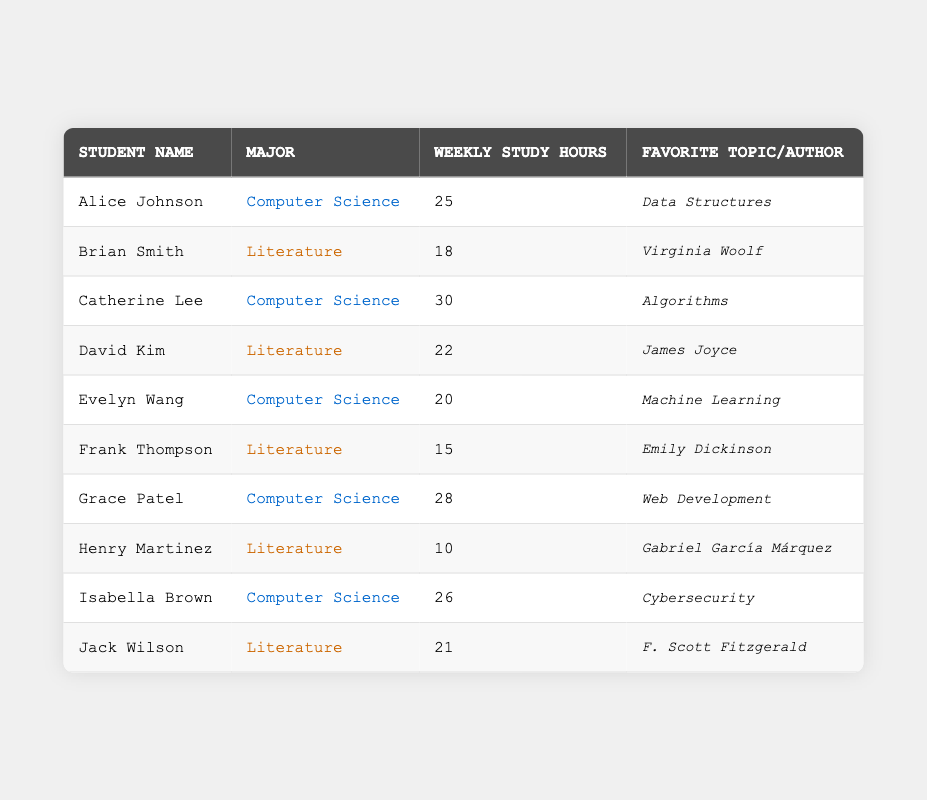What is the name of the student who studies the topic "Web Development"? In the table, I look for the "Favorite Topic" column and find "Web Development." The corresponding student name in that row is "Grace Patel."
Answer: Grace Patel What is the weekly study hour of Brian Smith? To find Brian Smith's study hours, I locate the row with his name in the table and read the value in the "Weekly Study Hours" column, which is 18.
Answer: 18 Which major has the highest weekly study hour among students in the table? I will compare the "Weekly Study Hours" of students in each major. For Computer Science, the highest value is 30 (Catherine Lee), and for Literature, it is 22 (David Kim). Therefore, the major with the highest hours is Computer Science.
Answer: Computer Science How many students study literature in the table? By counting the rows where the "Major" column contains "Literature," I find there are four students: Brian Smith, David Kim, Frank Thompson, and Henry Martinez.
Answer: 4 What is the total weekly study hours of all Computer Science students? I sum the weekly study hours of Computer Science students: 25 (Alice) + 30 (Catherine) + 20 (Evelyn) + 28 (Grace) + 26 (Isabella) = 129.
Answer: 129 Is Jack Wilson's favorite author James Joyce? I check Jack Wilson's row in the "Favorite Author" column, which shows he lists F. Scott Fitzgerald; therefore, Jack Wilson's favorite author is not James Joyce.
Answer: No Calculate the average weekly study hours of students majoring in literature. The weekly study hours of Literature students are: 18 (Brian) + 22 (David) + 15 (Frank) + 10 (Henry) + 21 (Jack) = 86. There are 5 literature students, so I divide the total by 5: 86 / 5 = 17.2.
Answer: 17.2 Which student studies the least and what is their weekly study hour? I assess the "Weekly Study Hours" of all students and find that Henry Martinez has the lowest value at 10 weekly study hours.
Answer: Henry Martinez, 10 How many more weekly study hours does Catherine Lee study compared to Frank Thompson? Frank Thompson studies 15 hours and Catherine Lee studies 30 hours. The difference is 30 - 15 = 15.
Answer: 15 Are there any students who study more than 25 hours weekly? I check the "Weekly Study Hours" column for values over 25. Alice (25), Catherine (30), Grace (28), and Isabella (26) all study more, so yes, there are students studying more than 25 hours.
Answer: Yes 